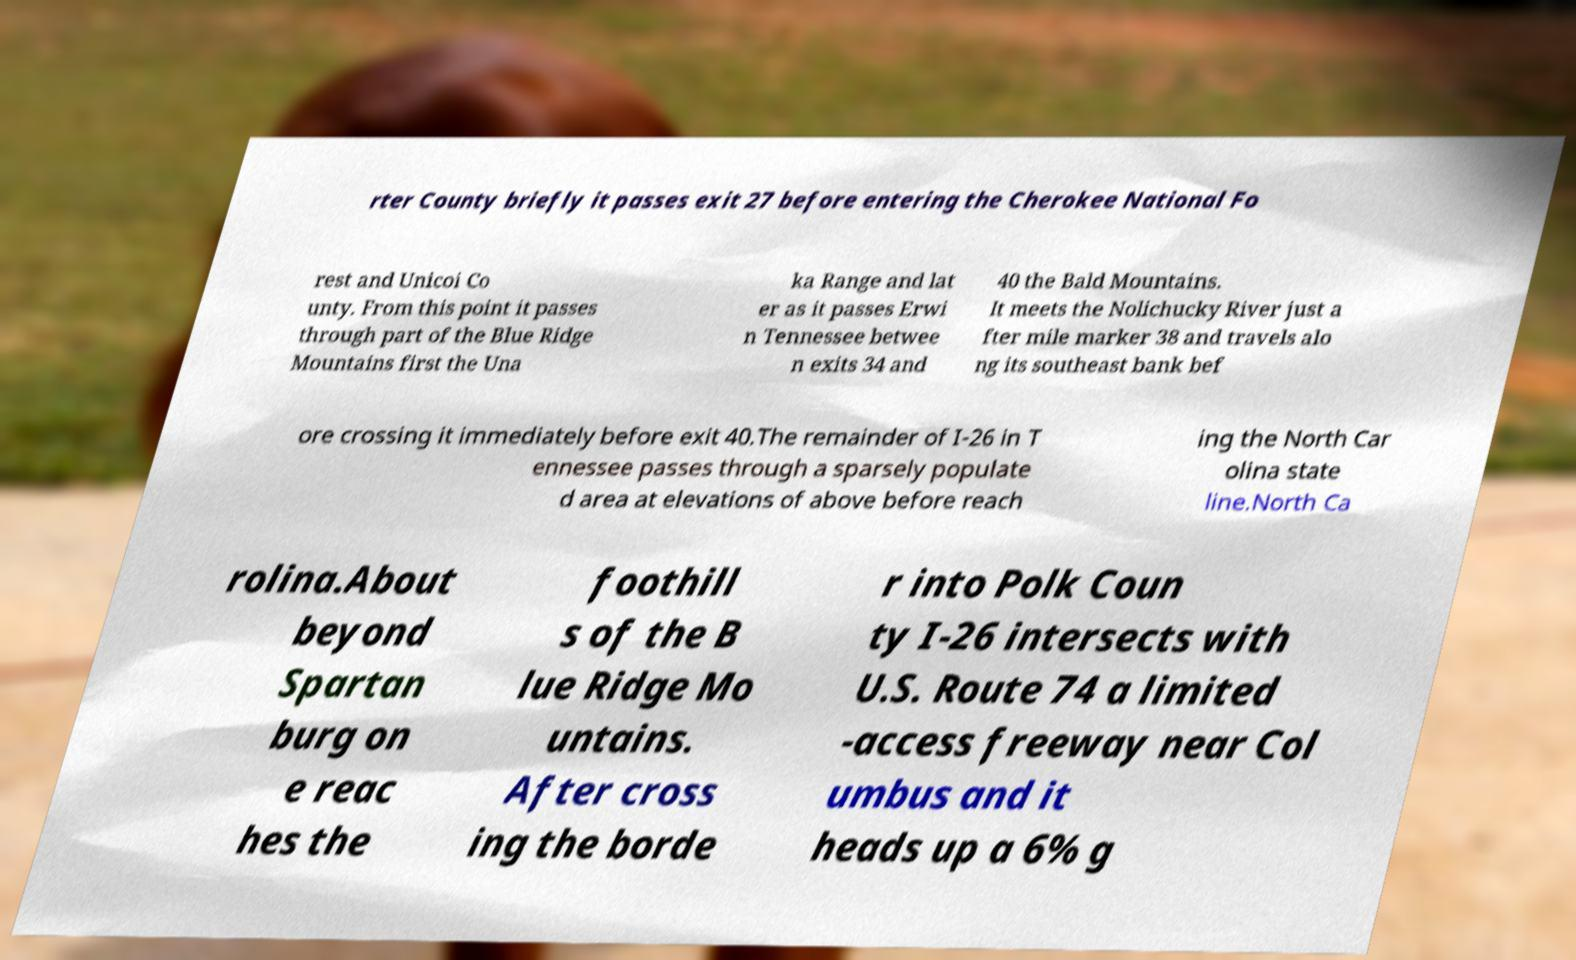For documentation purposes, I need the text within this image transcribed. Could you provide that? rter County briefly it passes exit 27 before entering the Cherokee National Fo rest and Unicoi Co unty. From this point it passes through part of the Blue Ridge Mountains first the Una ka Range and lat er as it passes Erwi n Tennessee betwee n exits 34 and 40 the Bald Mountains. It meets the Nolichucky River just a fter mile marker 38 and travels alo ng its southeast bank bef ore crossing it immediately before exit 40.The remainder of I-26 in T ennessee passes through a sparsely populate d area at elevations of above before reach ing the North Car olina state line.North Ca rolina.About beyond Spartan burg on e reac hes the foothill s of the B lue Ridge Mo untains. After cross ing the borde r into Polk Coun ty I-26 intersects with U.S. Route 74 a limited -access freeway near Col umbus and it heads up a 6% g 